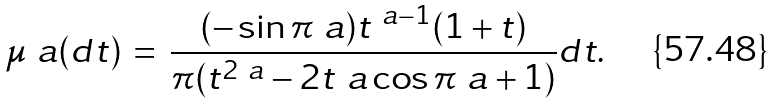Convert formula to latex. <formula><loc_0><loc_0><loc_500><loc_500>\mu _ { \ } a ( d t ) \, = \, \frac { ( - \sin \pi \ a ) t ^ { \ a - 1 } ( 1 + t ) } { \pi ( t ^ { 2 \ a } - 2 t ^ { \ } a \cos \pi \ a + 1 ) } d t .</formula> 